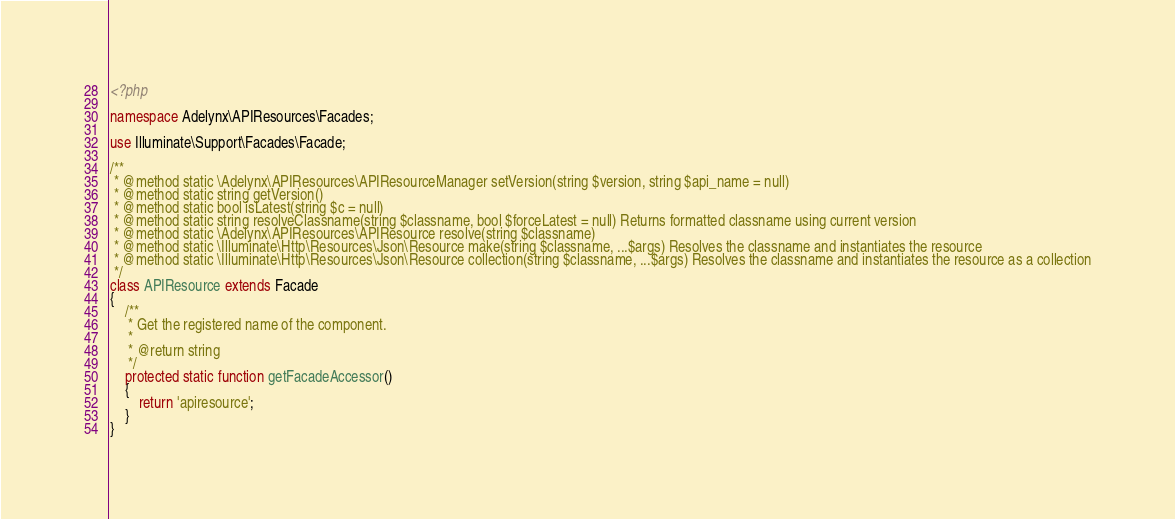<code> <loc_0><loc_0><loc_500><loc_500><_PHP_><?php

namespace Adelynx\APIResources\Facades;

use Illuminate\Support\Facades\Facade;

/**
 * @method static \Adelynx\APIResources\APIResourceManager setVersion(string $version, string $api_name = null)
 * @method static string getVersion()
 * @method static bool isLatest(string $c = null)
 * @method static string resolveClassname(string $classname, bool $forceLatest = null) Returns formatted classname using current version
 * @method static \Adelynx\APIResources\APIResource resolve(string $classname)
 * @method static \Illuminate\Http\Resources\Json\Resource make(string $classname, ...$args) Resolves the classname and instantiates the resource
 * @method static \Illuminate\Http\Resources\Json\Resource collection(string $classname, ...$args) Resolves the classname and instantiates the resource as a collection
 */
class APIResource extends Facade
{
    /**
     * Get the registered name of the component.
     *
     * @return string
     */
    protected static function getFacadeAccessor()
    {
        return 'apiresource';
    }
}
</code> 